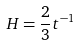Convert formula to latex. <formula><loc_0><loc_0><loc_500><loc_500>H = \frac { 2 } { 3 } t ^ { - 1 }</formula> 